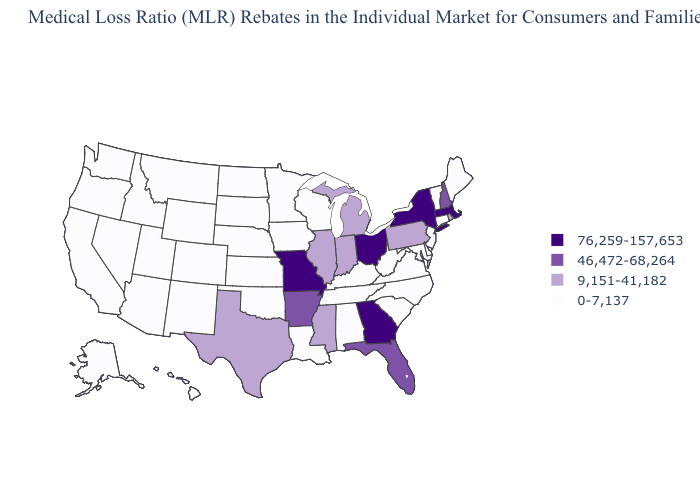What is the value of Louisiana?
Give a very brief answer. 0-7,137. What is the value of Minnesota?
Quick response, please. 0-7,137. Is the legend a continuous bar?
Short answer required. No. Name the states that have a value in the range 0-7,137?
Short answer required. Alabama, Alaska, Arizona, California, Colorado, Connecticut, Delaware, Hawaii, Idaho, Iowa, Kansas, Kentucky, Louisiana, Maine, Maryland, Minnesota, Montana, Nebraska, Nevada, New Jersey, New Mexico, North Carolina, North Dakota, Oklahoma, Oregon, South Carolina, South Dakota, Tennessee, Utah, Vermont, Virginia, Washington, West Virginia, Wisconsin, Wyoming. Name the states that have a value in the range 76,259-157,653?
Quick response, please. Georgia, Massachusetts, Missouri, New York, Ohio. Name the states that have a value in the range 0-7,137?
Answer briefly. Alabama, Alaska, Arizona, California, Colorado, Connecticut, Delaware, Hawaii, Idaho, Iowa, Kansas, Kentucky, Louisiana, Maine, Maryland, Minnesota, Montana, Nebraska, Nevada, New Jersey, New Mexico, North Carolina, North Dakota, Oklahoma, Oregon, South Carolina, South Dakota, Tennessee, Utah, Vermont, Virginia, Washington, West Virginia, Wisconsin, Wyoming. Is the legend a continuous bar?
Give a very brief answer. No. Among the states that border Missouri , does Kentucky have the lowest value?
Concise answer only. Yes. What is the value of South Dakota?
Give a very brief answer. 0-7,137. What is the lowest value in states that border Arizona?
Be succinct. 0-7,137. What is the lowest value in the West?
Answer briefly. 0-7,137. Which states have the lowest value in the USA?
Be succinct. Alabama, Alaska, Arizona, California, Colorado, Connecticut, Delaware, Hawaii, Idaho, Iowa, Kansas, Kentucky, Louisiana, Maine, Maryland, Minnesota, Montana, Nebraska, Nevada, New Jersey, New Mexico, North Carolina, North Dakota, Oklahoma, Oregon, South Carolina, South Dakota, Tennessee, Utah, Vermont, Virginia, Washington, West Virginia, Wisconsin, Wyoming. Does the first symbol in the legend represent the smallest category?
Quick response, please. No. Name the states that have a value in the range 76,259-157,653?
Short answer required. Georgia, Massachusetts, Missouri, New York, Ohio. 